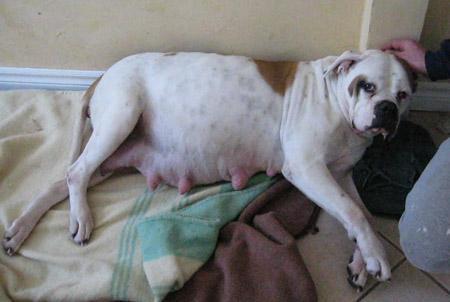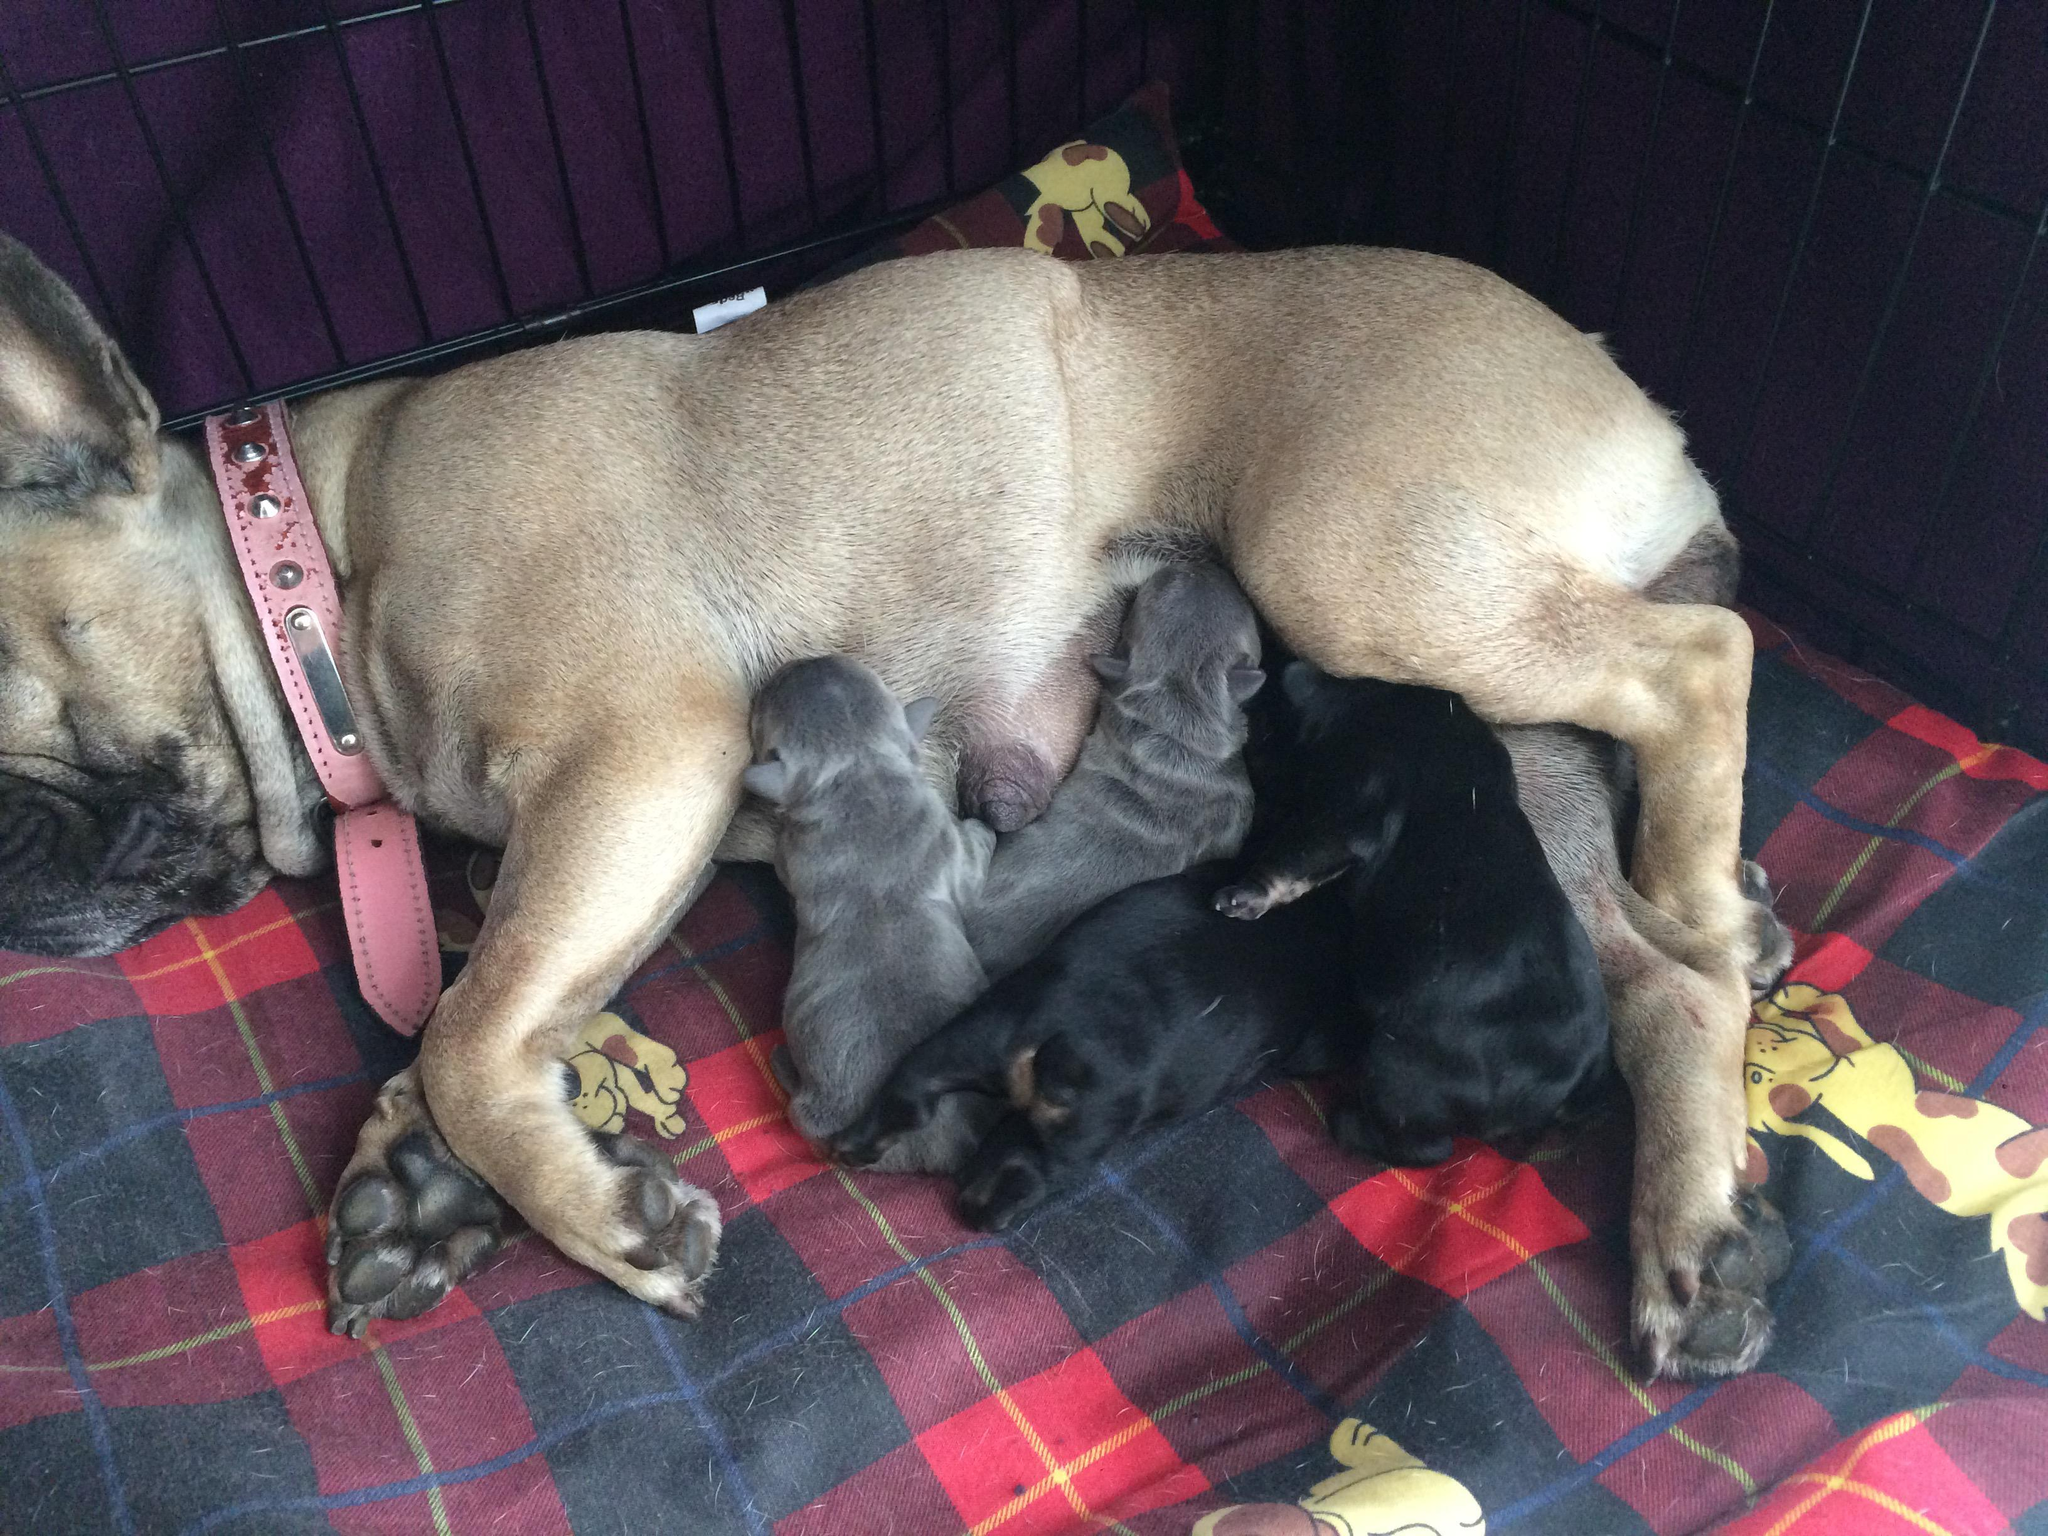The first image is the image on the left, the second image is the image on the right. Assess this claim about the two images: "The right image contains an adult dog nursing her puppies.". Correct or not? Answer yes or no. Yes. The first image is the image on the left, the second image is the image on the right. For the images displayed, is the sentence "A mother dog is laying on her side feeding at least 3 puppies." factually correct? Answer yes or no. Yes. 